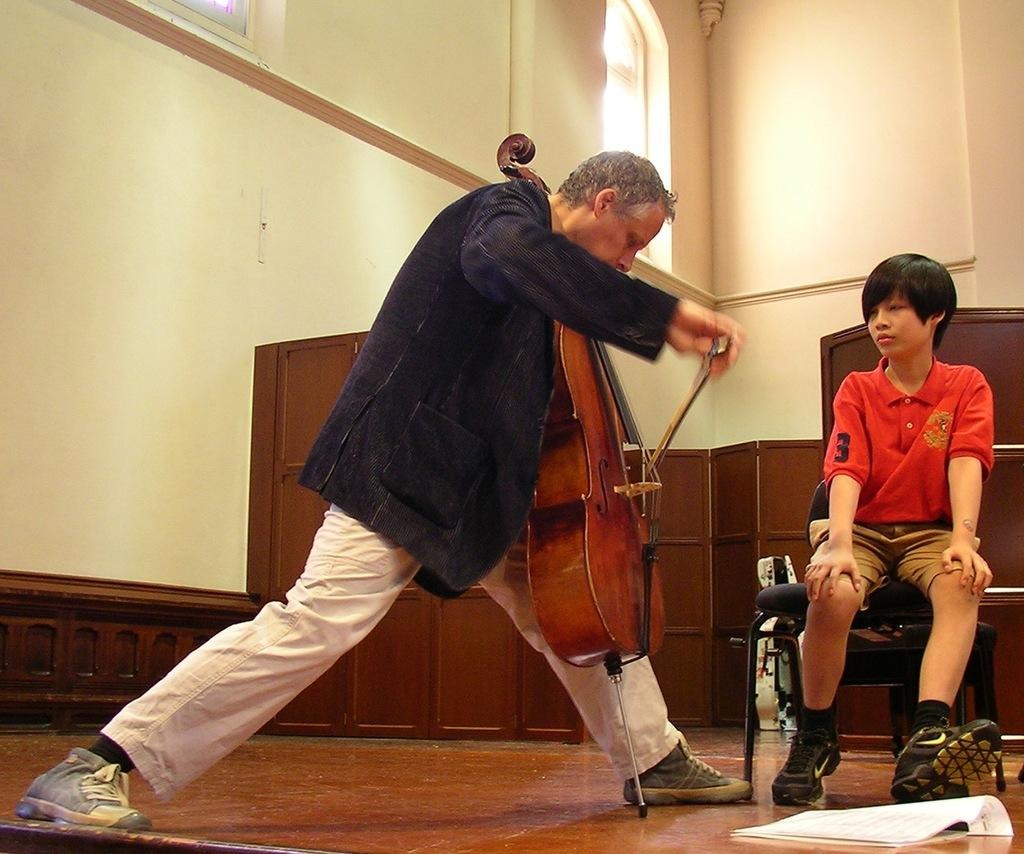What is the man in the image doing? The man is standing in the image and holding a musical instrument. Who else is present in the image? There is a boy sitting on a chair in the image. What can be seen on the floor in the image? There is a paper on the floor in the image. What type of beast is the man riding in the image? There is no beast present in the image, and the man is not riding anything. 